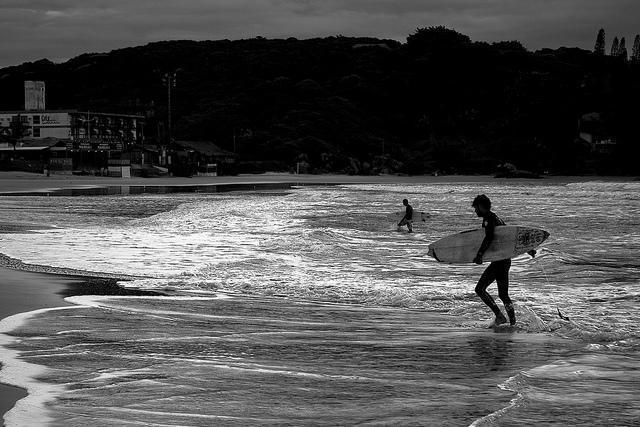What is the problem with this photo?
Answer the question by selecting the correct answer among the 4 following choices.
Options: Too bright, blurred, photoshopped, too dark. Too dark. 